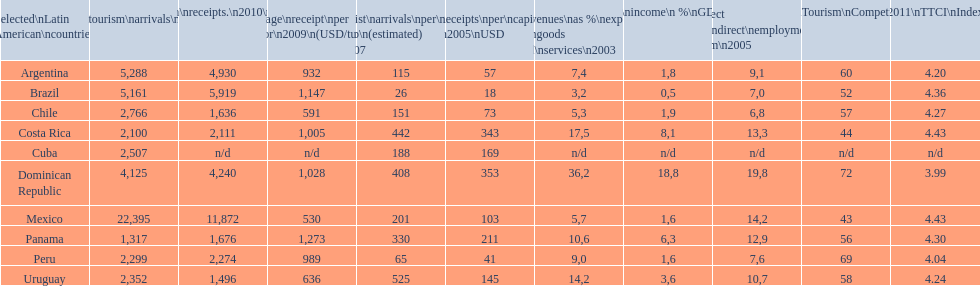Which nation tops the list in numerous classifications? Dominican Republic. 